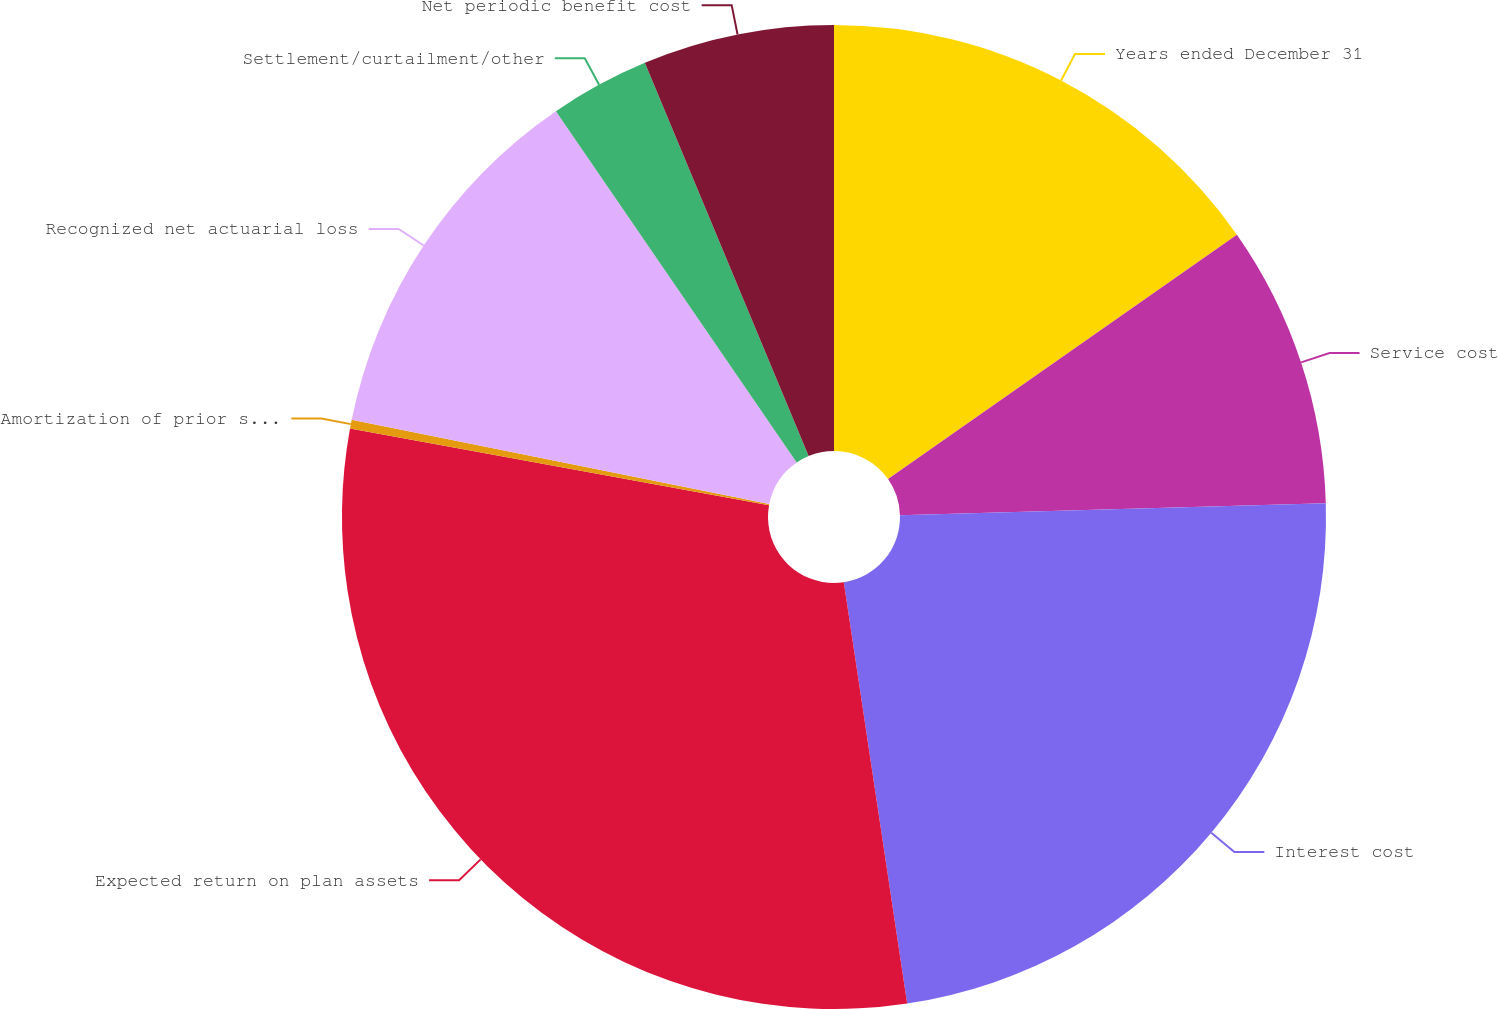<chart> <loc_0><loc_0><loc_500><loc_500><pie_chart><fcel>Years ended December 31<fcel>Service cost<fcel>Interest cost<fcel>Expected return on plan assets<fcel>Amortization of prior service<fcel>Recognized net actuarial loss<fcel>Settlement/curtailment/other<fcel>Net periodic benefit cost<nl><fcel>15.27%<fcel>9.28%<fcel>23.07%<fcel>30.25%<fcel>0.29%<fcel>12.27%<fcel>3.28%<fcel>6.28%<nl></chart> 